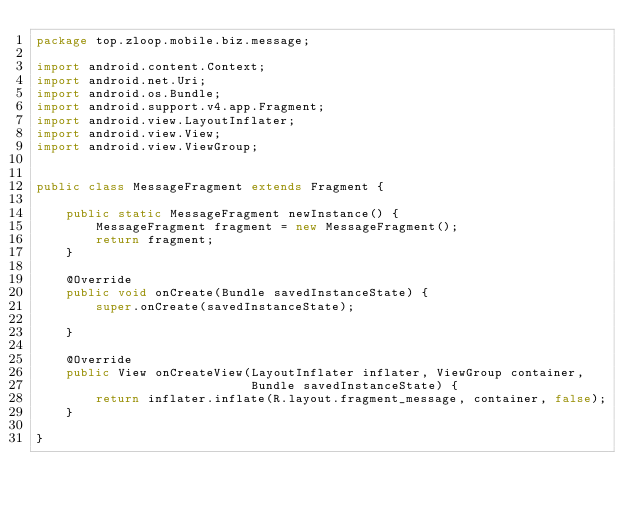<code> <loc_0><loc_0><loc_500><loc_500><_Java_>package top.zloop.mobile.biz.message;

import android.content.Context;
import android.net.Uri;
import android.os.Bundle;
import android.support.v4.app.Fragment;
import android.view.LayoutInflater;
import android.view.View;
import android.view.ViewGroup;


public class MessageFragment extends Fragment {

    public static MessageFragment newInstance() {
        MessageFragment fragment = new MessageFragment();
        return fragment;
    }

    @Override
    public void onCreate(Bundle savedInstanceState) {
        super.onCreate(savedInstanceState);

    }

    @Override
    public View onCreateView(LayoutInflater inflater, ViewGroup container,
                             Bundle savedInstanceState) {
        return inflater.inflate(R.layout.fragment_message, container, false);
    }

}
</code> 